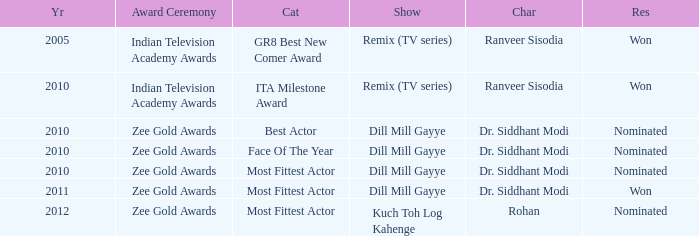Which show was nominated for the ITA Milestone Award at the Indian Television Academy Awards? Remix (TV series). 